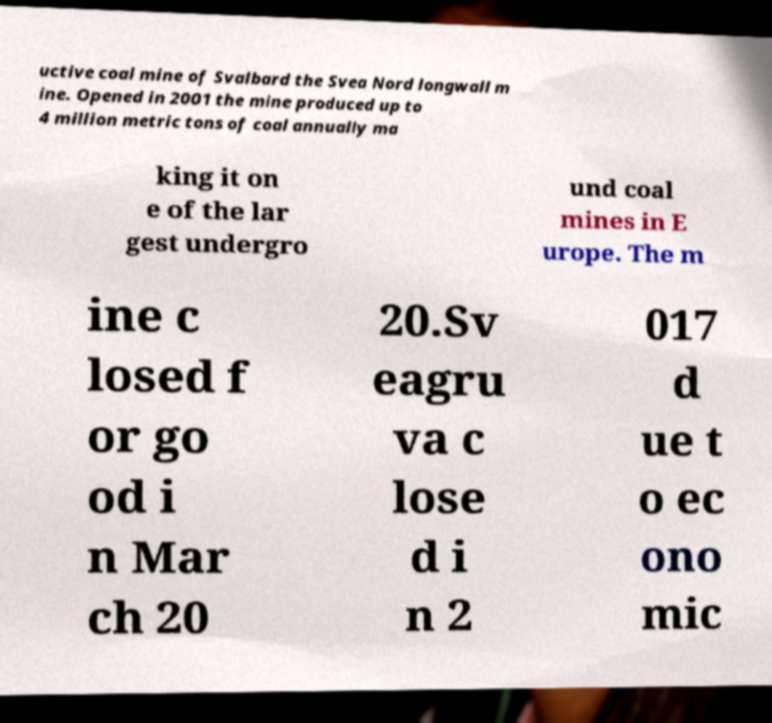Could you extract and type out the text from this image? uctive coal mine of Svalbard the Svea Nord longwall m ine. Opened in 2001 the mine produced up to 4 million metric tons of coal annually ma king it on e of the lar gest undergro und coal mines in E urope. The m ine c losed f or go od i n Mar ch 20 20.Sv eagru va c lose d i n 2 017 d ue t o ec ono mic 